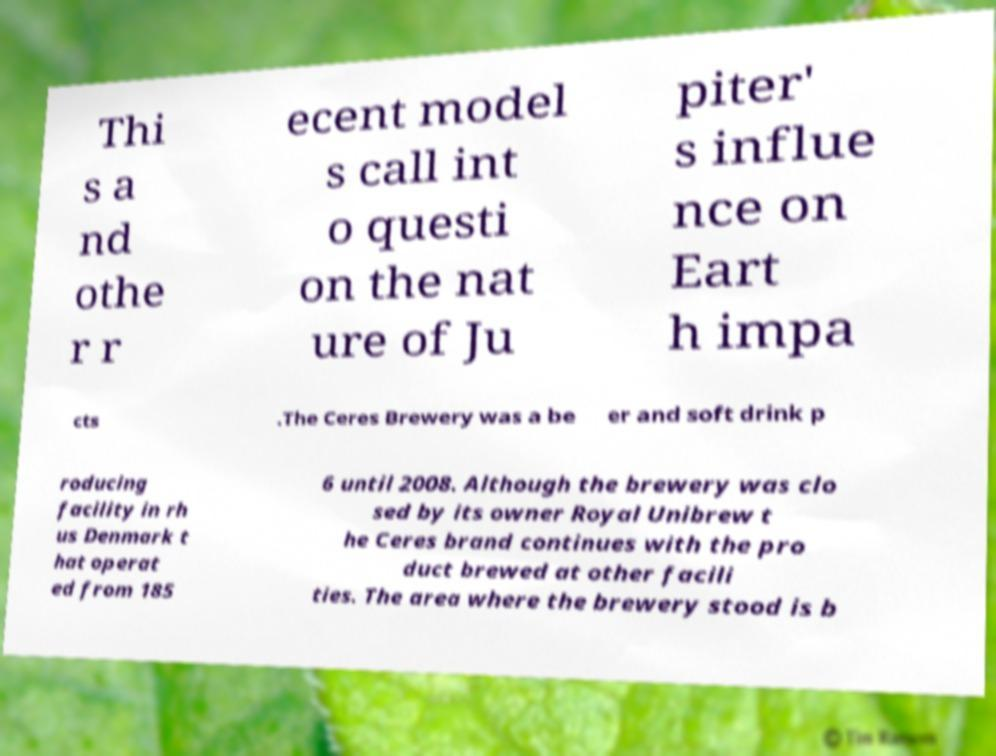Can you accurately transcribe the text from the provided image for me? Thi s a nd othe r r ecent model s call int o questi on the nat ure of Ju piter' s influe nce on Eart h impa cts .The Ceres Brewery was a be er and soft drink p roducing facility in rh us Denmark t hat operat ed from 185 6 until 2008. Although the brewery was clo sed by its owner Royal Unibrew t he Ceres brand continues with the pro duct brewed at other facili ties. The area where the brewery stood is b 